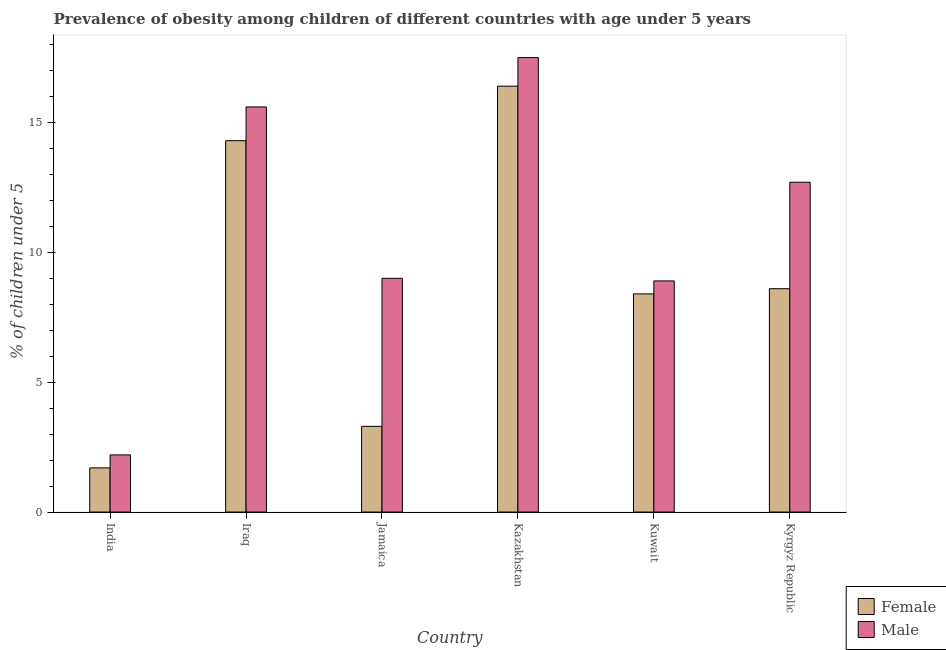Are the number of bars on each tick of the X-axis equal?
Keep it short and to the point. Yes. How many bars are there on the 3rd tick from the right?
Provide a succinct answer. 2. What is the label of the 5th group of bars from the left?
Ensure brevity in your answer.  Kuwait. In how many cases, is the number of bars for a given country not equal to the number of legend labels?
Keep it short and to the point. 0. What is the percentage of obese male children in India?
Your answer should be compact. 2.2. Across all countries, what is the maximum percentage of obese female children?
Provide a short and direct response. 16.4. Across all countries, what is the minimum percentage of obese male children?
Provide a short and direct response. 2.2. In which country was the percentage of obese female children maximum?
Provide a short and direct response. Kazakhstan. In which country was the percentage of obese male children minimum?
Your response must be concise. India. What is the total percentage of obese female children in the graph?
Ensure brevity in your answer.  52.7. What is the difference between the percentage of obese male children in India and that in Kuwait?
Your response must be concise. -6.7. What is the difference between the percentage of obese male children in Kazakhstan and the percentage of obese female children in India?
Give a very brief answer. 15.8. What is the average percentage of obese female children per country?
Ensure brevity in your answer.  8.78. What is the difference between the percentage of obese male children and percentage of obese female children in Jamaica?
Make the answer very short. 5.7. In how many countries, is the percentage of obese female children greater than 3 %?
Ensure brevity in your answer.  5. What is the ratio of the percentage of obese female children in India to that in Kazakhstan?
Provide a short and direct response. 0.1. Is the percentage of obese female children in Iraq less than that in Kyrgyz Republic?
Your answer should be very brief. No. What is the difference between the highest and the second highest percentage of obese female children?
Your response must be concise. 2.1. What is the difference between the highest and the lowest percentage of obese male children?
Make the answer very short. 15.3. Is the sum of the percentage of obese female children in Kazakhstan and Kyrgyz Republic greater than the maximum percentage of obese male children across all countries?
Your response must be concise. Yes. What does the 1st bar from the right in Jamaica represents?
Offer a very short reply. Male. How many countries are there in the graph?
Provide a succinct answer. 6. What is the difference between two consecutive major ticks on the Y-axis?
Provide a short and direct response. 5. Does the graph contain any zero values?
Ensure brevity in your answer.  No. Where does the legend appear in the graph?
Provide a succinct answer. Bottom right. How many legend labels are there?
Offer a very short reply. 2. What is the title of the graph?
Provide a short and direct response. Prevalence of obesity among children of different countries with age under 5 years. Does "All education staff compensation" appear as one of the legend labels in the graph?
Your answer should be very brief. No. What is the label or title of the X-axis?
Provide a short and direct response. Country. What is the label or title of the Y-axis?
Offer a very short reply.  % of children under 5. What is the  % of children under 5 of Female in India?
Your response must be concise. 1.7. What is the  % of children under 5 in Male in India?
Provide a succinct answer. 2.2. What is the  % of children under 5 in Female in Iraq?
Your response must be concise. 14.3. What is the  % of children under 5 of Male in Iraq?
Offer a very short reply. 15.6. What is the  % of children under 5 of Female in Jamaica?
Provide a succinct answer. 3.3. What is the  % of children under 5 of Male in Jamaica?
Ensure brevity in your answer.  9. What is the  % of children under 5 in Female in Kazakhstan?
Provide a short and direct response. 16.4. What is the  % of children under 5 of Male in Kazakhstan?
Your response must be concise. 17.5. What is the  % of children under 5 in Female in Kuwait?
Your response must be concise. 8.4. What is the  % of children under 5 in Male in Kuwait?
Your response must be concise. 8.9. What is the  % of children under 5 of Female in Kyrgyz Republic?
Ensure brevity in your answer.  8.6. What is the  % of children under 5 of Male in Kyrgyz Republic?
Give a very brief answer. 12.7. Across all countries, what is the maximum  % of children under 5 in Female?
Offer a very short reply. 16.4. Across all countries, what is the minimum  % of children under 5 in Female?
Provide a short and direct response. 1.7. Across all countries, what is the minimum  % of children under 5 in Male?
Ensure brevity in your answer.  2.2. What is the total  % of children under 5 of Female in the graph?
Keep it short and to the point. 52.7. What is the total  % of children under 5 of Male in the graph?
Your response must be concise. 65.9. What is the difference between the  % of children under 5 of Female in India and that in Iraq?
Provide a short and direct response. -12.6. What is the difference between the  % of children under 5 in Female in India and that in Jamaica?
Your answer should be compact. -1.6. What is the difference between the  % of children under 5 of Female in India and that in Kazakhstan?
Provide a succinct answer. -14.7. What is the difference between the  % of children under 5 in Male in India and that in Kazakhstan?
Offer a very short reply. -15.3. What is the difference between the  % of children under 5 of Male in India and that in Kyrgyz Republic?
Ensure brevity in your answer.  -10.5. What is the difference between the  % of children under 5 of Male in Iraq and that in Jamaica?
Offer a terse response. 6.6. What is the difference between the  % of children under 5 of Female in Iraq and that in Kuwait?
Provide a succinct answer. 5.9. What is the difference between the  % of children under 5 in Male in Iraq and that in Kuwait?
Your answer should be compact. 6.7. What is the difference between the  % of children under 5 in Male in Iraq and that in Kyrgyz Republic?
Make the answer very short. 2.9. What is the difference between the  % of children under 5 of Male in Jamaica and that in Kazakhstan?
Your response must be concise. -8.5. What is the difference between the  % of children under 5 of Female in Jamaica and that in Kuwait?
Your response must be concise. -5.1. What is the difference between the  % of children under 5 in Female in Jamaica and that in Kyrgyz Republic?
Your answer should be compact. -5.3. What is the difference between the  % of children under 5 in Male in Jamaica and that in Kyrgyz Republic?
Provide a short and direct response. -3.7. What is the difference between the  % of children under 5 of Male in Kazakhstan and that in Kuwait?
Offer a terse response. 8.6. What is the difference between the  % of children under 5 of Female in Kazakhstan and that in Kyrgyz Republic?
Provide a short and direct response. 7.8. What is the difference between the  % of children under 5 of Male in Kazakhstan and that in Kyrgyz Republic?
Your answer should be very brief. 4.8. What is the difference between the  % of children under 5 of Male in Kuwait and that in Kyrgyz Republic?
Give a very brief answer. -3.8. What is the difference between the  % of children under 5 in Female in India and the  % of children under 5 in Male in Kazakhstan?
Your answer should be compact. -15.8. What is the difference between the  % of children under 5 in Female in Iraq and the  % of children under 5 in Male in Kazakhstan?
Offer a very short reply. -3.2. What is the difference between the  % of children under 5 of Female in Iraq and the  % of children under 5 of Male in Kyrgyz Republic?
Offer a terse response. 1.6. What is the difference between the  % of children under 5 of Female in Kazakhstan and the  % of children under 5 of Male in Kyrgyz Republic?
Your response must be concise. 3.7. What is the average  % of children under 5 of Female per country?
Your answer should be compact. 8.78. What is the average  % of children under 5 in Male per country?
Make the answer very short. 10.98. What is the difference between the  % of children under 5 in Female and  % of children under 5 in Male in India?
Give a very brief answer. -0.5. What is the difference between the  % of children under 5 in Female and  % of children under 5 in Male in Jamaica?
Offer a very short reply. -5.7. What is the difference between the  % of children under 5 in Female and  % of children under 5 in Male in Kazakhstan?
Offer a terse response. -1.1. What is the ratio of the  % of children under 5 in Female in India to that in Iraq?
Your response must be concise. 0.12. What is the ratio of the  % of children under 5 in Male in India to that in Iraq?
Your answer should be compact. 0.14. What is the ratio of the  % of children under 5 of Female in India to that in Jamaica?
Offer a terse response. 0.52. What is the ratio of the  % of children under 5 of Male in India to that in Jamaica?
Make the answer very short. 0.24. What is the ratio of the  % of children under 5 in Female in India to that in Kazakhstan?
Ensure brevity in your answer.  0.1. What is the ratio of the  % of children under 5 of Male in India to that in Kazakhstan?
Your response must be concise. 0.13. What is the ratio of the  % of children under 5 of Female in India to that in Kuwait?
Ensure brevity in your answer.  0.2. What is the ratio of the  % of children under 5 in Male in India to that in Kuwait?
Your response must be concise. 0.25. What is the ratio of the  % of children under 5 in Female in India to that in Kyrgyz Republic?
Give a very brief answer. 0.2. What is the ratio of the  % of children under 5 in Male in India to that in Kyrgyz Republic?
Your response must be concise. 0.17. What is the ratio of the  % of children under 5 of Female in Iraq to that in Jamaica?
Offer a very short reply. 4.33. What is the ratio of the  % of children under 5 of Male in Iraq to that in Jamaica?
Offer a terse response. 1.73. What is the ratio of the  % of children under 5 in Female in Iraq to that in Kazakhstan?
Your response must be concise. 0.87. What is the ratio of the  % of children under 5 in Male in Iraq to that in Kazakhstan?
Keep it short and to the point. 0.89. What is the ratio of the  % of children under 5 of Female in Iraq to that in Kuwait?
Make the answer very short. 1.7. What is the ratio of the  % of children under 5 in Male in Iraq to that in Kuwait?
Your answer should be very brief. 1.75. What is the ratio of the  % of children under 5 of Female in Iraq to that in Kyrgyz Republic?
Offer a very short reply. 1.66. What is the ratio of the  % of children under 5 of Male in Iraq to that in Kyrgyz Republic?
Offer a very short reply. 1.23. What is the ratio of the  % of children under 5 of Female in Jamaica to that in Kazakhstan?
Your answer should be very brief. 0.2. What is the ratio of the  % of children under 5 of Male in Jamaica to that in Kazakhstan?
Make the answer very short. 0.51. What is the ratio of the  % of children under 5 in Female in Jamaica to that in Kuwait?
Your answer should be compact. 0.39. What is the ratio of the  % of children under 5 in Male in Jamaica to that in Kuwait?
Your answer should be compact. 1.01. What is the ratio of the  % of children under 5 in Female in Jamaica to that in Kyrgyz Republic?
Your answer should be very brief. 0.38. What is the ratio of the  % of children under 5 in Male in Jamaica to that in Kyrgyz Republic?
Give a very brief answer. 0.71. What is the ratio of the  % of children under 5 in Female in Kazakhstan to that in Kuwait?
Provide a short and direct response. 1.95. What is the ratio of the  % of children under 5 in Male in Kazakhstan to that in Kuwait?
Make the answer very short. 1.97. What is the ratio of the  % of children under 5 in Female in Kazakhstan to that in Kyrgyz Republic?
Your response must be concise. 1.91. What is the ratio of the  % of children under 5 in Male in Kazakhstan to that in Kyrgyz Republic?
Your answer should be compact. 1.38. What is the ratio of the  % of children under 5 of Female in Kuwait to that in Kyrgyz Republic?
Provide a short and direct response. 0.98. What is the ratio of the  % of children under 5 of Male in Kuwait to that in Kyrgyz Republic?
Provide a short and direct response. 0.7. What is the difference between the highest and the second highest  % of children under 5 in Female?
Give a very brief answer. 2.1. What is the difference between the highest and the lowest  % of children under 5 in Female?
Ensure brevity in your answer.  14.7. 